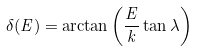<formula> <loc_0><loc_0><loc_500><loc_500>\delta ( E ) = \arctan \left ( \frac { E } { k } \tan \lambda \right )</formula> 